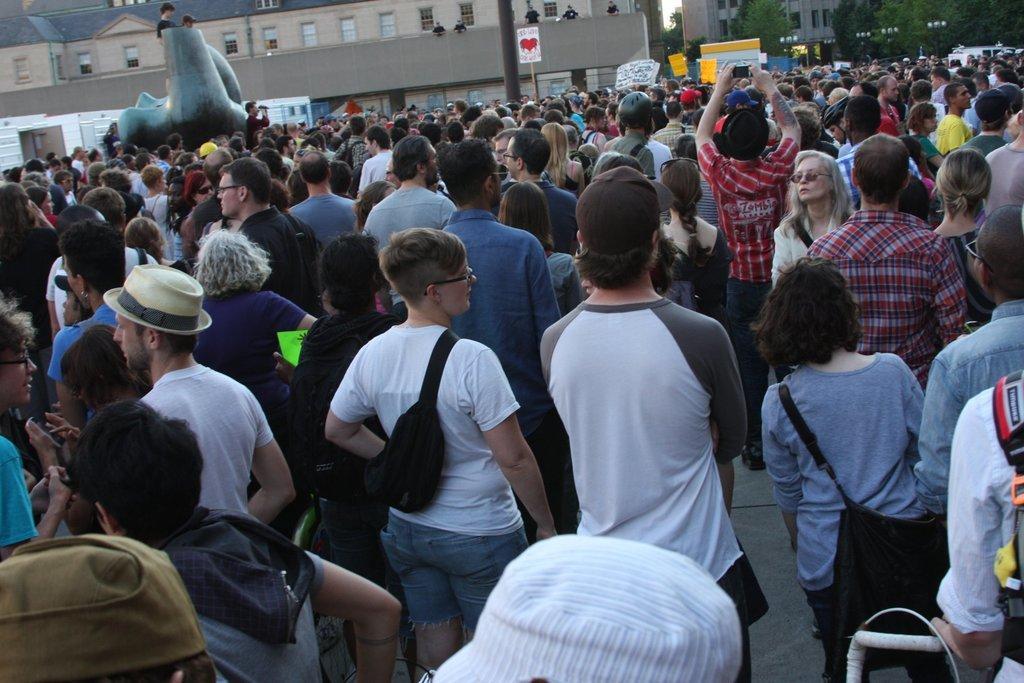How would you summarize this image in a sentence or two? In this picture there are many people in the center of the image and there are buildings and trees at the top side of the image, there are posters in the center of the image. 